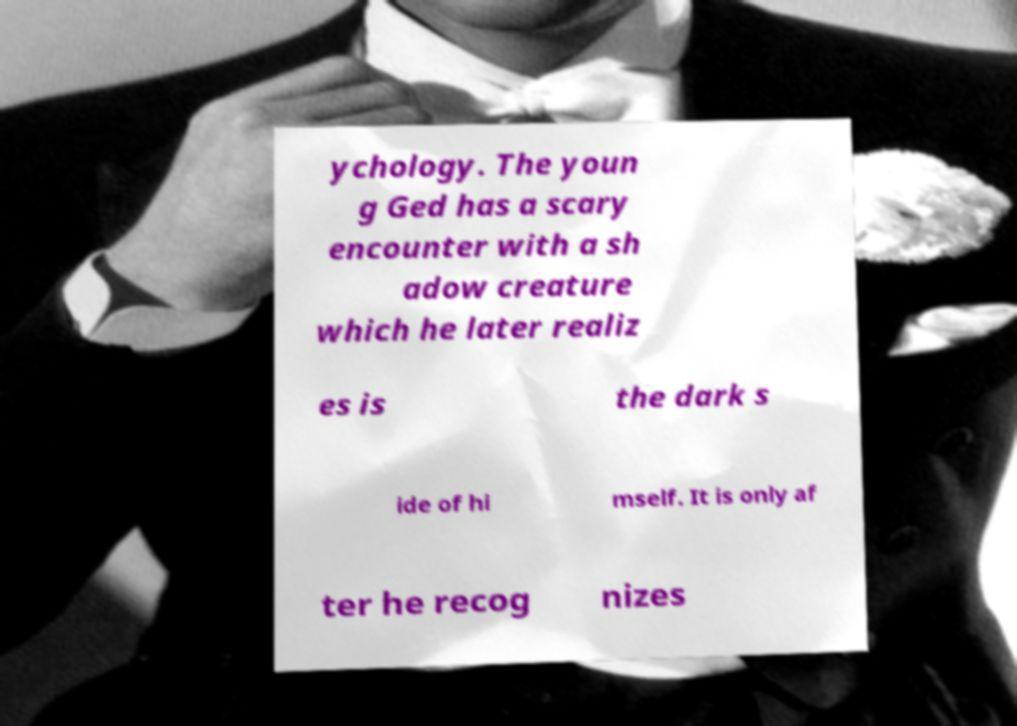There's text embedded in this image that I need extracted. Can you transcribe it verbatim? ychology. The youn g Ged has a scary encounter with a sh adow creature which he later realiz es is the dark s ide of hi mself. It is only af ter he recog nizes 